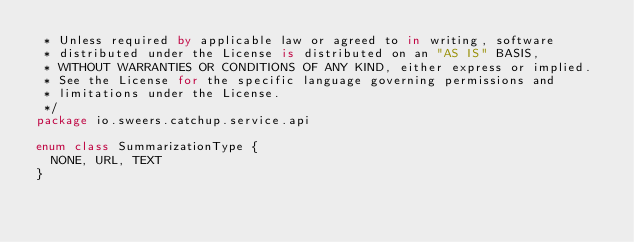<code> <loc_0><loc_0><loc_500><loc_500><_Kotlin_> * Unless required by applicable law or agreed to in writing, software
 * distributed under the License is distributed on an "AS IS" BASIS,
 * WITHOUT WARRANTIES OR CONDITIONS OF ANY KIND, either express or implied.
 * See the License for the specific language governing permissions and
 * limitations under the License.
 */
package io.sweers.catchup.service.api

enum class SummarizationType {
  NONE, URL, TEXT
}
</code> 